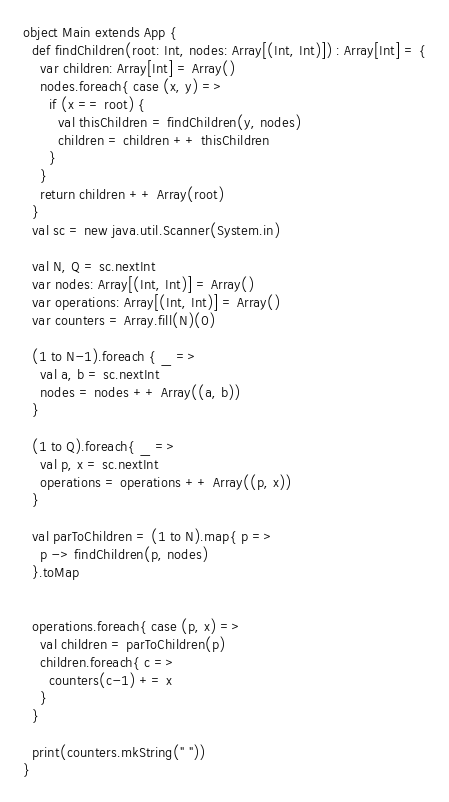Convert code to text. <code><loc_0><loc_0><loc_500><loc_500><_Scala_>object Main extends App {
  def findChildren(root: Int, nodes: Array[(Int, Int)]) : Array[Int] = {
    var children: Array[Int] = Array()
    nodes.foreach{ case (x, y) =>
      if (x == root) {
        val thisChildren = findChildren(y, nodes)
        children = children ++ thisChildren
      }
    }
    return children ++ Array(root)
  }
  val sc = new java.util.Scanner(System.in)

  val N, Q = sc.nextInt
  var nodes: Array[(Int, Int)] = Array()
  var operations: Array[(Int, Int)] = Array()
  var counters = Array.fill(N)(0)

  (1 to N-1).foreach { _ =>
    val a, b = sc.nextInt
    nodes = nodes ++ Array((a, b))
  }

  (1 to Q).foreach{ _ =>
    val p, x = sc.nextInt
  	operations = operations ++ Array((p, x))
  }

  val parToChildren = (1 to N).map{ p =>
    p -> findChildren(p, nodes)
  }.toMap


  operations.foreach{ case (p, x) =>
    val children = parToChildren(p)
    children.foreach{ c =>
      counters(c-1) += x
    }
  }

  print(counters.mkString(" "))
}</code> 